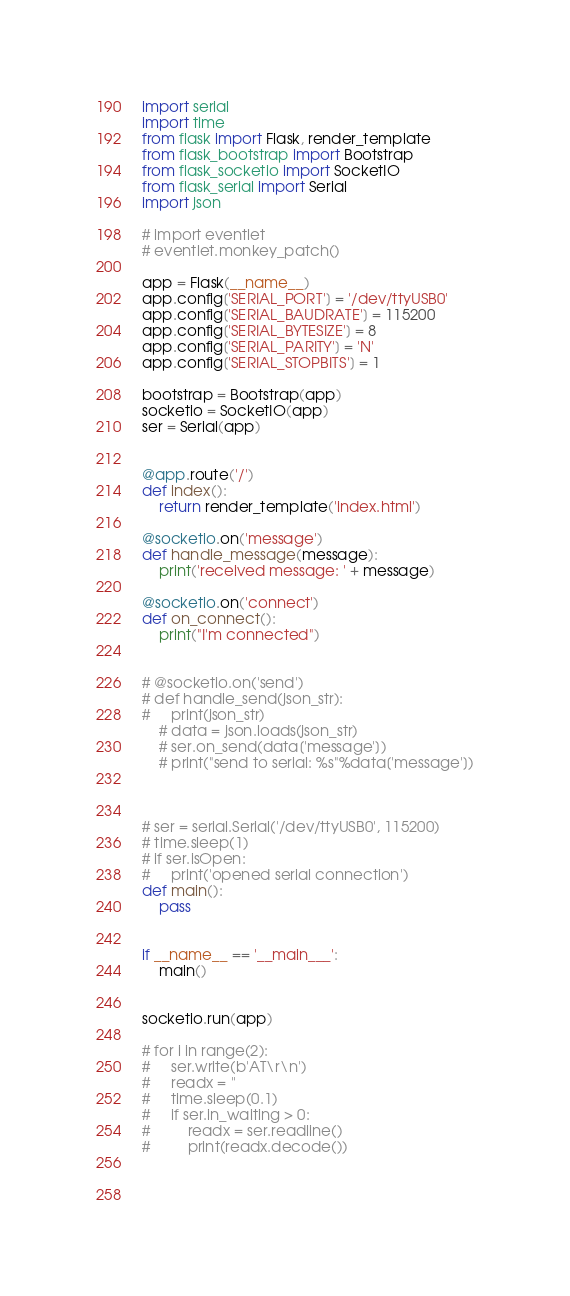<code> <loc_0><loc_0><loc_500><loc_500><_Python_>import serial
import time
from flask import Flask, render_template
from flask_bootstrap import Bootstrap
from flask_socketio import SocketIO
from flask_serial import Serial
import json

# import eventlet
# eventlet.monkey_patch()

app = Flask(__name__)
app.config['SERIAL_PORT'] = '/dev/ttyUSB0'
app.config['SERIAL_BAUDRATE'] = 115200
app.config['SERIAL_BYTESIZE'] = 8
app.config['SERIAL_PARITY'] = 'N'
app.config['SERIAL_STOPBITS'] = 1

bootstrap = Bootstrap(app)
socketio = SocketIO(app)
ser = Serial(app)


@app.route('/')
def index():
    return render_template('index.html')

@socketio.on('message')
def handle_message(message):
    print('received message: ' + message)

@socketio.on('connect')
def on_connect():
    print("I'm connected")


# @socketio.on('send')
# def handle_send(json_str):
#     print(json_str)
    # data = json.loads(json_str)
    # ser.on_send(data['message'])
    # print("send to serial: %s"%data['message'])



# ser = serial.Serial('/dev/ttyUSB0', 115200)
# time.sleep(1)
# if ser.isOpen: 
#     print('opened serial connection')
def main():
    pass


if __name__ == '__main___':
    main()


socketio.run(app)

# for i in range(2):
#     ser.write(b'AT\r\n')
#     readx = ''
#     time.sleep(0.1)
#     if ser.in_waiting > 0:
#         readx = ser.readline()
#         print(readx.decode())
    
    
    </code> 